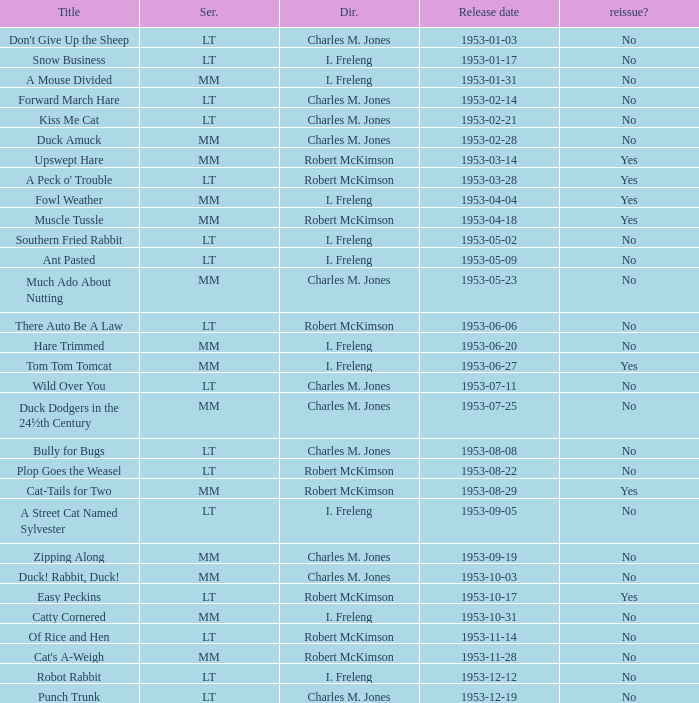What's the release date of Upswept Hare? 1953-03-14. 